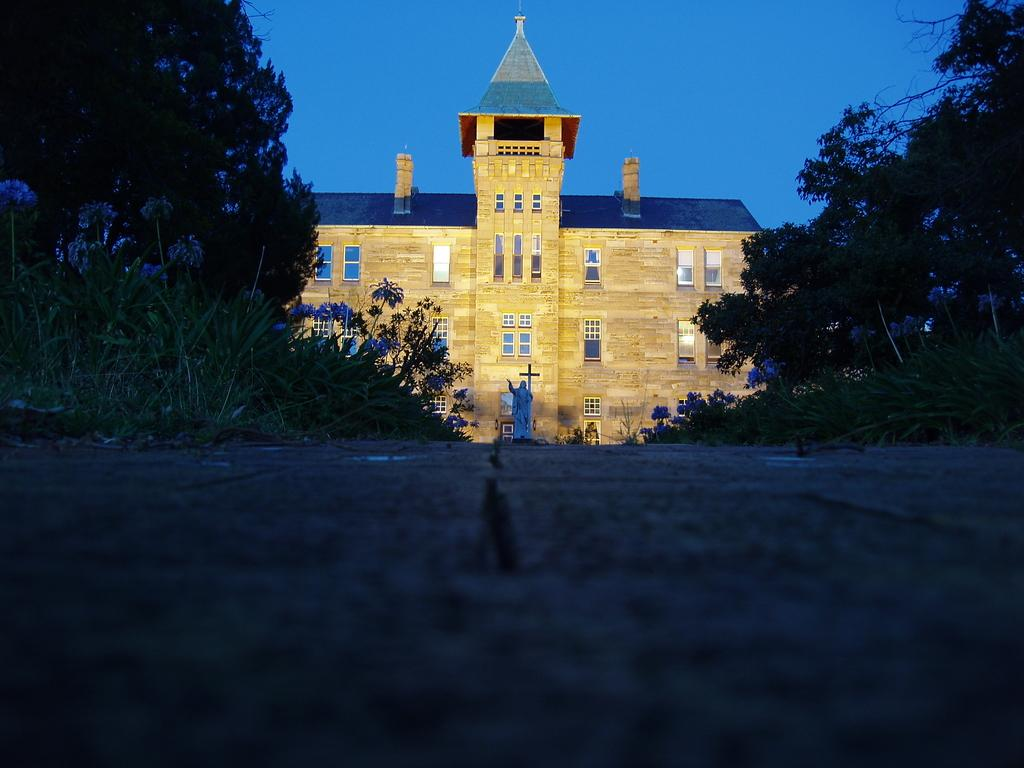What is the main feature of the image? There is a road in the image. What can be seen alongside the road? The road is surrounded by plants and trees. What structure is present near the road? There is a statue in front of a building. What is visible at the top of the image? The sky is visible at the top of the image. Is there any poison visible in the image? There is no mention of poison or any dangerous substances in the provided facts, and nothing in the image suggests the presence of poison. --- Facts: 1. There is a person sitting on a bench. 2. The person is reading a book. 3. There is a tree behind the bench. 4. The sky is visible at the top of the image. Absurd Topics: parrot, bicycle, ocean Conversation: What is the person in the image doing? The person is sitting on a bench and reading a book. What can be seen behind the bench? There is a tree behind the bench. What is visible at the top of the image? The sky is visible at the top of the image. Reasoning: Let's think step by step in order to produce the conversation. We start by identifying the main subject in the image, which is the person sitting on the bench. Then, we expand the conversation to include the person's activity, which is reading a book. We also mention the tree behind the bench and the sky visible at the top of the image. Each question is designed to elicit a specific detail about the image that is known from the provided facts. Absurd Question/Answer: Can you see a parrot perched on the tree in the image? There is no mention of a parrot or any animals in the provided facts, and nothing in the image suggests the presence of a parrot. --- Facts: 1. There is a car in the image. 2. The car is parked on the street. 3. There are buildings in the background. 